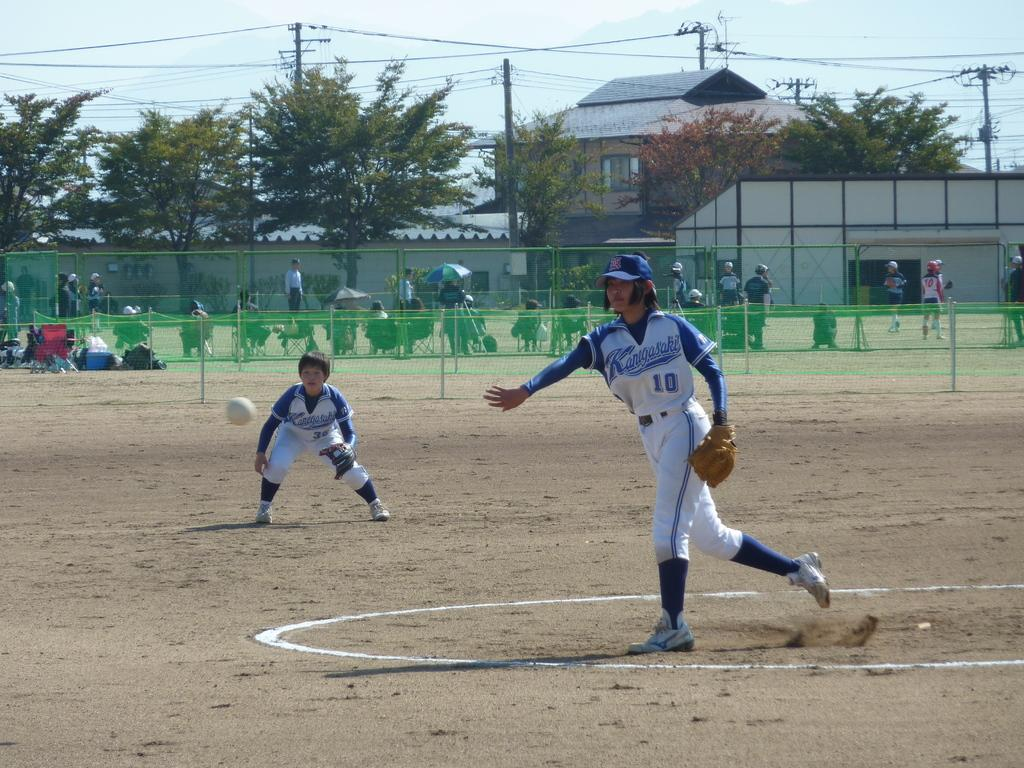<image>
Provide a brief description of the given image. the number 10 is on the front of a jersey 